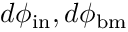Convert formula to latex. <formula><loc_0><loc_0><loc_500><loc_500>d \phi _ { i n } , d \phi _ { b m }</formula> 